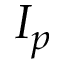Convert formula to latex. <formula><loc_0><loc_0><loc_500><loc_500>I _ { p }</formula> 